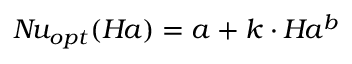Convert formula to latex. <formula><loc_0><loc_0><loc_500><loc_500>N \, u _ { o p t } ( H \, a ) = a + k \cdot H \, a ^ { b }</formula> 